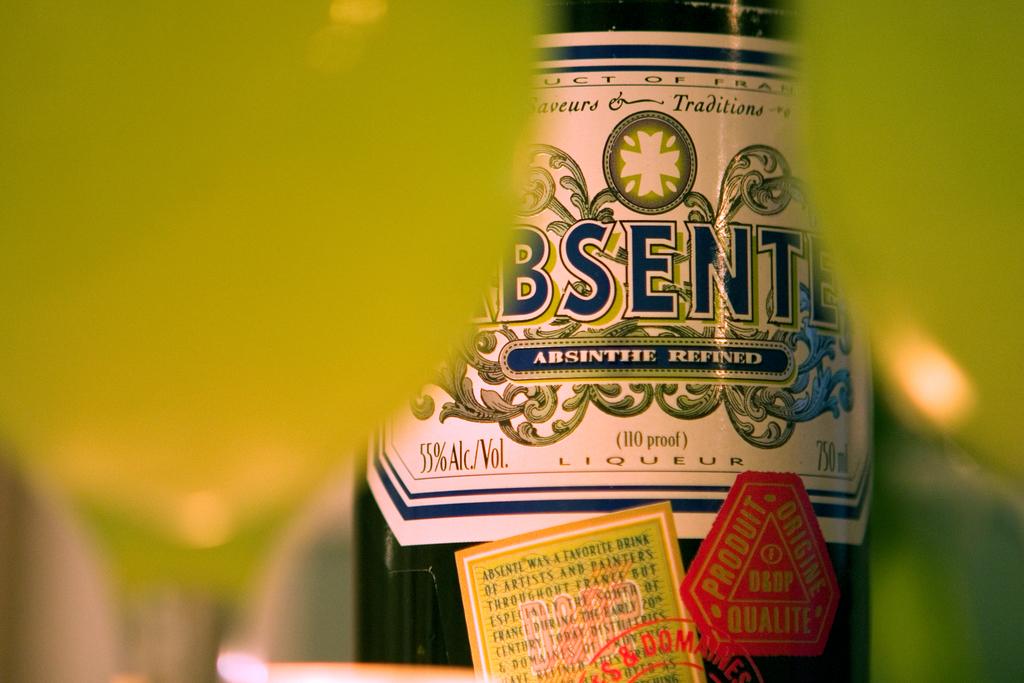What is the alc. % of this liqueur?
Provide a short and direct response. 55%. What volume is in the bottle?
Keep it short and to the point. 55%. 